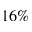Convert formula to latex. <formula><loc_0><loc_0><loc_500><loc_500>1 6 \%</formula> 